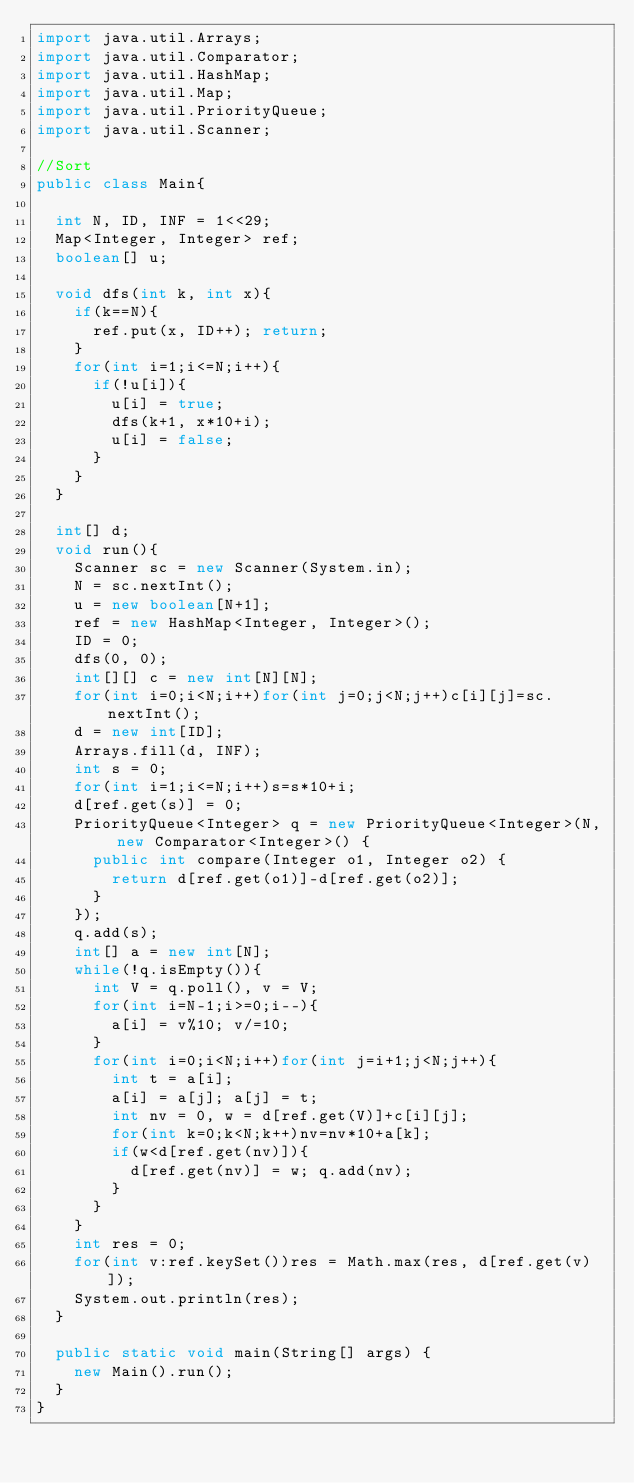Convert code to text. <code><loc_0><loc_0><loc_500><loc_500><_Java_>import java.util.Arrays;
import java.util.Comparator;
import java.util.HashMap;
import java.util.Map;
import java.util.PriorityQueue;
import java.util.Scanner;

//Sort
public class Main{

	int N, ID, INF = 1<<29;
	Map<Integer, Integer> ref;
	boolean[] u;
	
	void dfs(int k, int x){
		if(k==N){
			ref.put(x, ID++); return;
		}
		for(int i=1;i<=N;i++){
			if(!u[i]){
				u[i] = true;
				dfs(k+1, x*10+i);
				u[i] = false;
			}
		}
	}
	
	int[] d;
	void run(){
		Scanner sc = new Scanner(System.in);
		N = sc.nextInt();
		u = new boolean[N+1];
		ref = new HashMap<Integer, Integer>();
		ID = 0;
		dfs(0, 0);
		int[][] c = new int[N][N];
		for(int i=0;i<N;i++)for(int j=0;j<N;j++)c[i][j]=sc.nextInt();
		d = new int[ID];
		Arrays.fill(d, INF);
		int s = 0;
		for(int i=1;i<=N;i++)s=s*10+i;
		d[ref.get(s)] = 0;
		PriorityQueue<Integer> q = new PriorityQueue<Integer>(N, new Comparator<Integer>() {
			public int compare(Integer o1, Integer o2) {
				return d[ref.get(o1)]-d[ref.get(o2)];
			}
		});
		q.add(s);
		int[] a = new int[N];
		while(!q.isEmpty()){
			int V = q.poll(), v = V;
			for(int i=N-1;i>=0;i--){
				a[i] = v%10; v/=10;
			}
			for(int i=0;i<N;i++)for(int j=i+1;j<N;j++){
				int t = a[i];
				a[i] = a[j]; a[j] = t;
				int nv = 0, w = d[ref.get(V)]+c[i][j];
				for(int k=0;k<N;k++)nv=nv*10+a[k];
				if(w<d[ref.get(nv)]){
					d[ref.get(nv)] = w; q.add(nv);
				}
			}
		}
		int res = 0;
		for(int v:ref.keySet())res = Math.max(res, d[ref.get(v)]);
		System.out.println(res);
	}
	
	public static void main(String[] args) {
		new Main().run();
	}
}</code> 